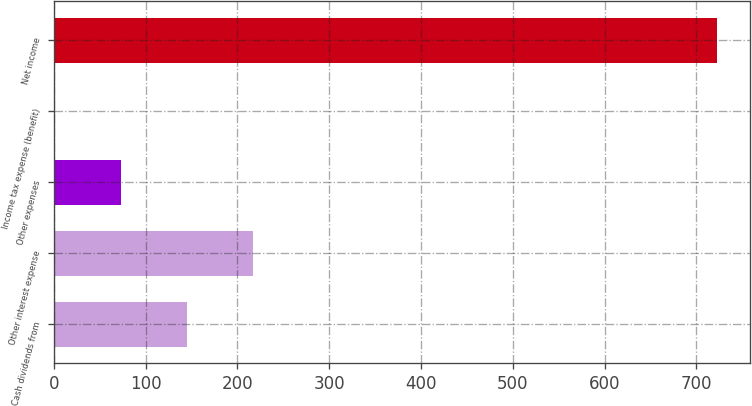Convert chart to OTSL. <chart><loc_0><loc_0><loc_500><loc_500><bar_chart><fcel>Cash dividends from<fcel>Other interest expense<fcel>Other expenses<fcel>Income tax expense (benefit)<fcel>Net income<nl><fcel>145.2<fcel>217.3<fcel>73.1<fcel>1<fcel>722<nl></chart> 